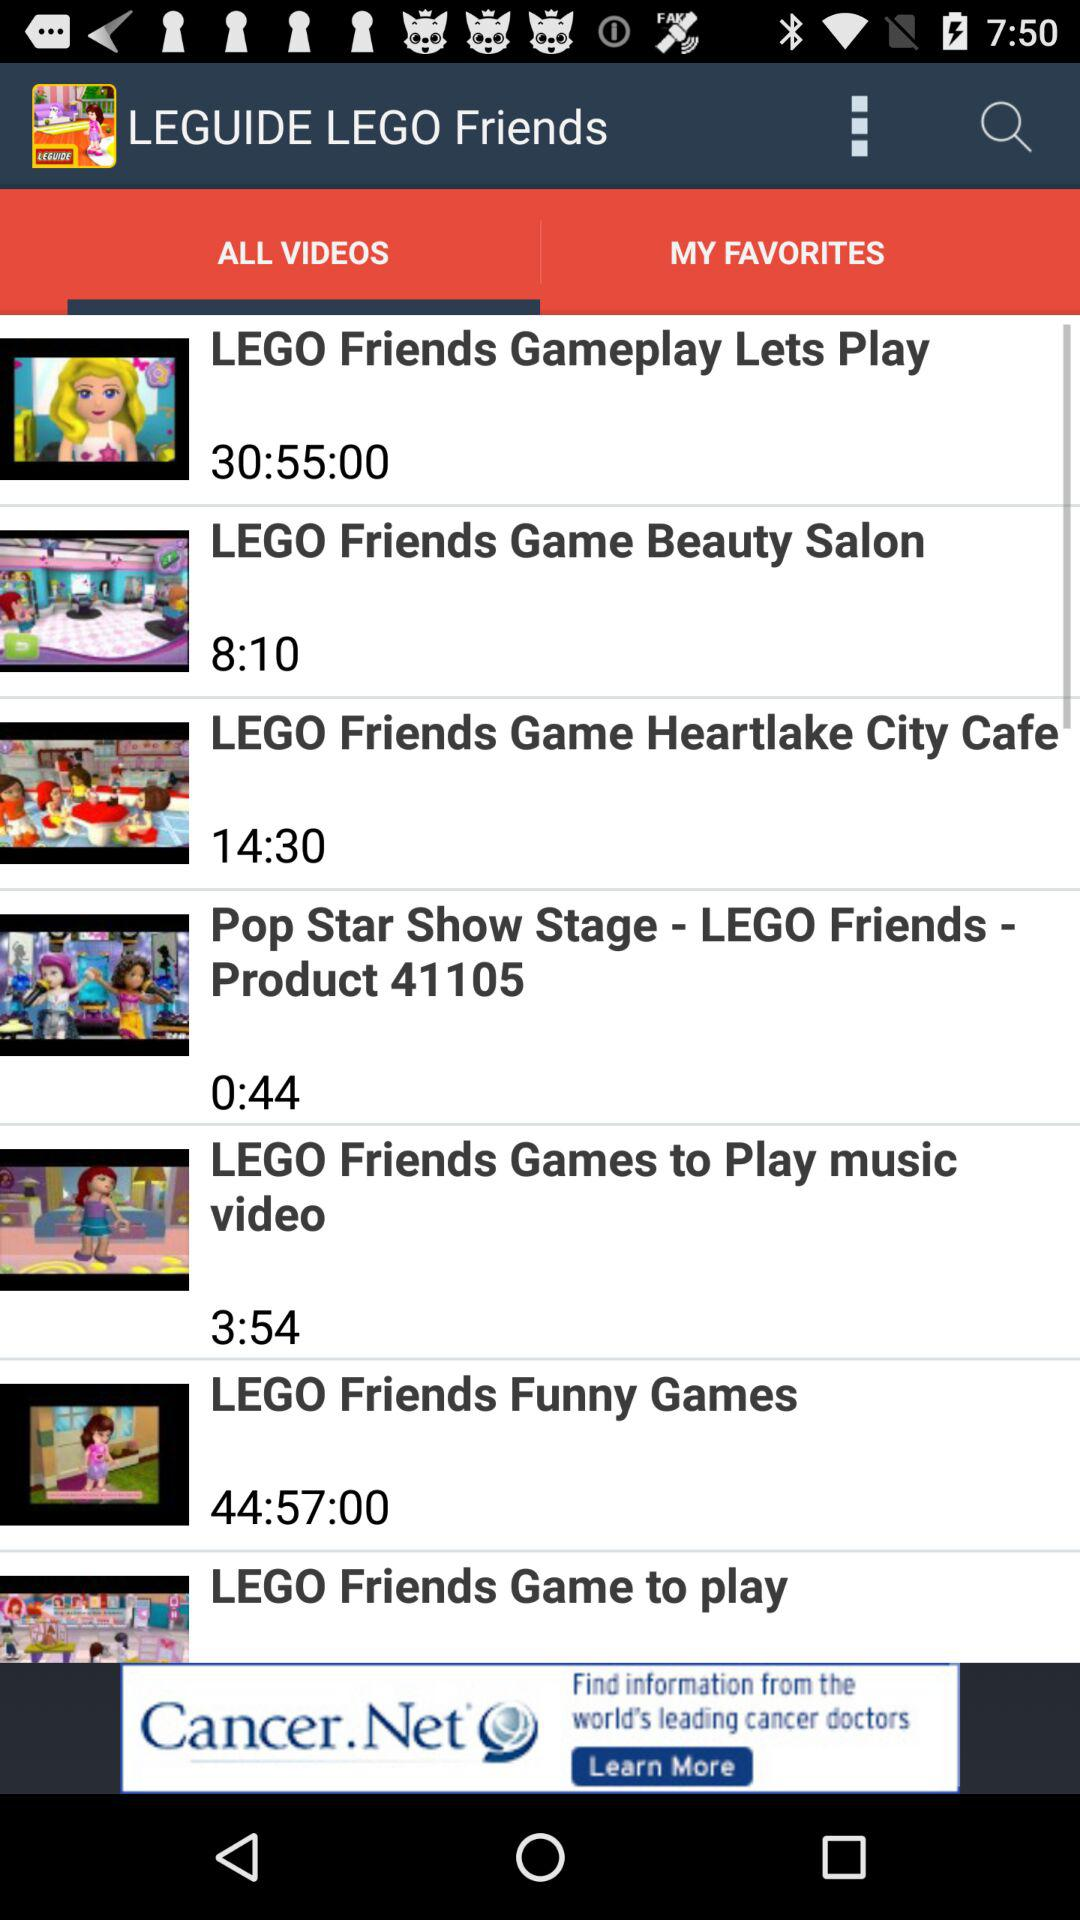How long does it take for "LEGO Friends Funny Games" to finish? It takes 44 hours 57 minutes for "LEGO Friends Funny Games" to finish. 